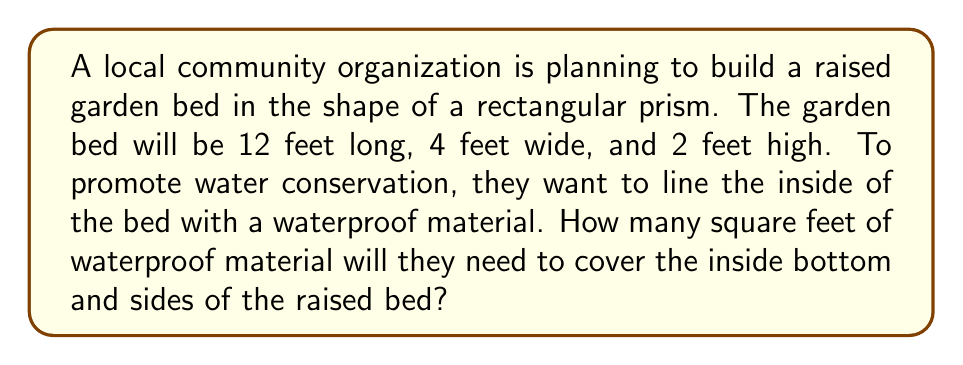Could you help me with this problem? To solve this problem, we need to calculate the surface area of the inside of the rectangular prism, excluding the top face. Let's break it down step-by-step:

1. Identify the dimensions:
   Length (l) = 12 feet
   Width (w) = 4 feet
   Height (h) = 2 feet

2. Calculate the area of the bottom:
   $$A_{bottom} = l \times w = 12 \text{ ft} \times 4 \text{ ft} = 48 \text{ ft}^2$$

3. Calculate the area of the two long sides:
   $$A_{long sides} = 2 \times (l \times h) = 2 \times (12 \text{ ft} \times 2 \text{ ft}) = 48 \text{ ft}^2$$

4. Calculate the area of the two short sides:
   $$A_{short sides} = 2 \times (w \times h) = 2 \times (4 \text{ ft} \times 2 \text{ ft}) = 16 \text{ ft}^2$$

5. Sum up all the areas:
   $$A_{total} = A_{bottom} + A_{long sides} + A_{short sides}$$
   $$A_{total} = 48 \text{ ft}^2 + 48 \text{ ft}^2 + 16 \text{ ft}^2 = 112 \text{ ft}^2$$

Therefore, the community organization will need 112 square feet of waterproof material to line the inside of the raised garden bed.

[asy]
import three;

size(200);
currentprojection=perspective(6,3,2);

draw(cuboid((0,0,0),(12,4,2)),blue);
draw((0,0,0)--(12,0,0)--(12,4,0)--(0,4,0)--cycle,red);
draw((0,0,0)--(0,0,2)--(12,0,2)--(12,0,0),red);
draw((0,0,0)--(0,0,2)--(0,4,2)--(0,4,0),red);

label("12 ft",(6,0,0),S);
label("4 ft",(12,2,0),E);
label("2 ft",(0,0,1),W);
[/asy]
Answer: 112 square feet 